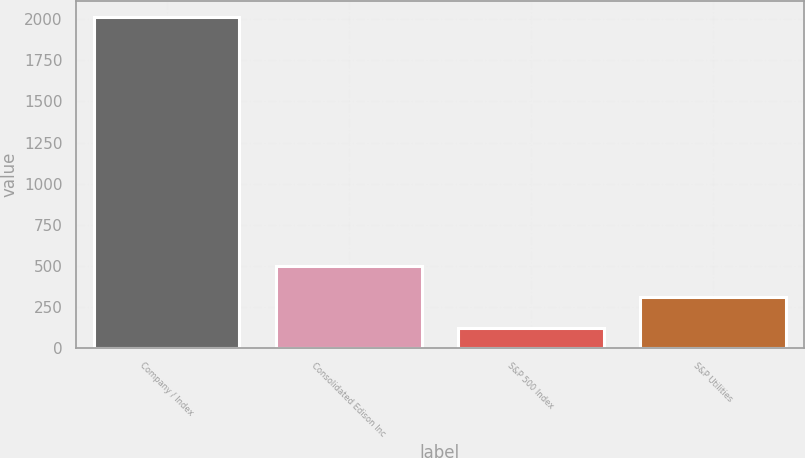Convert chart to OTSL. <chart><loc_0><loc_0><loc_500><loc_500><bar_chart><fcel>Company / Index<fcel>Consolidated Edison Inc<fcel>S&P 500 Index<fcel>S&P Utilities<nl><fcel>2012<fcel>497.17<fcel>118.45<fcel>307.81<nl></chart> 